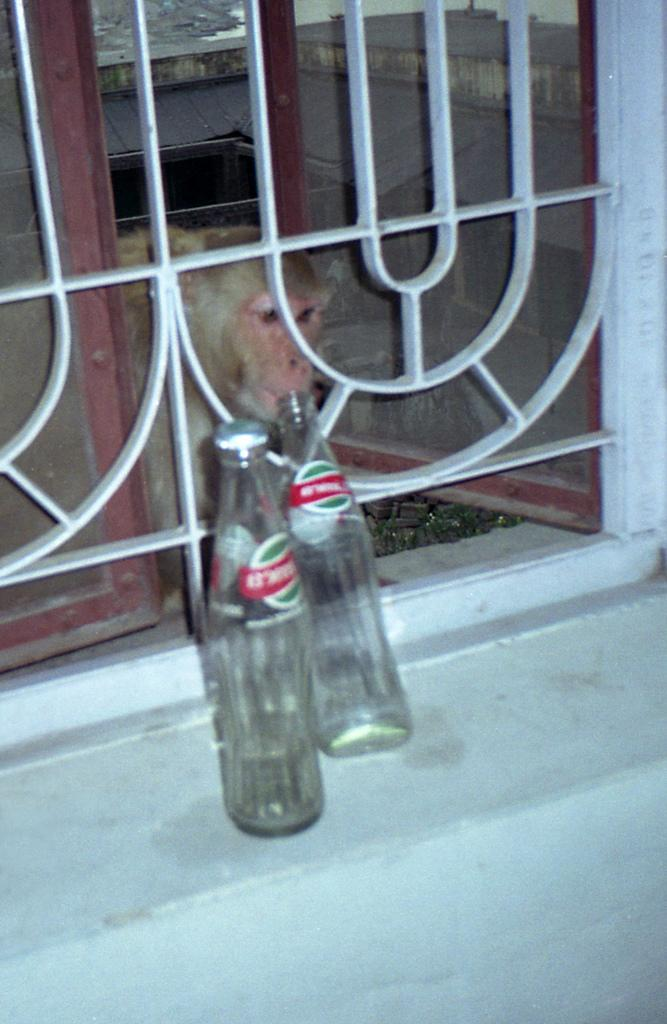What animal is present in the image? There is a monkey in the image. Where is the monkey located in relation to the window? The monkey is behind a window. How many bottles can be seen in the image? There are two bottles in the image. What type of question is being asked by the monkey in the image? There is no indication in the image that the monkey is asking a question. 